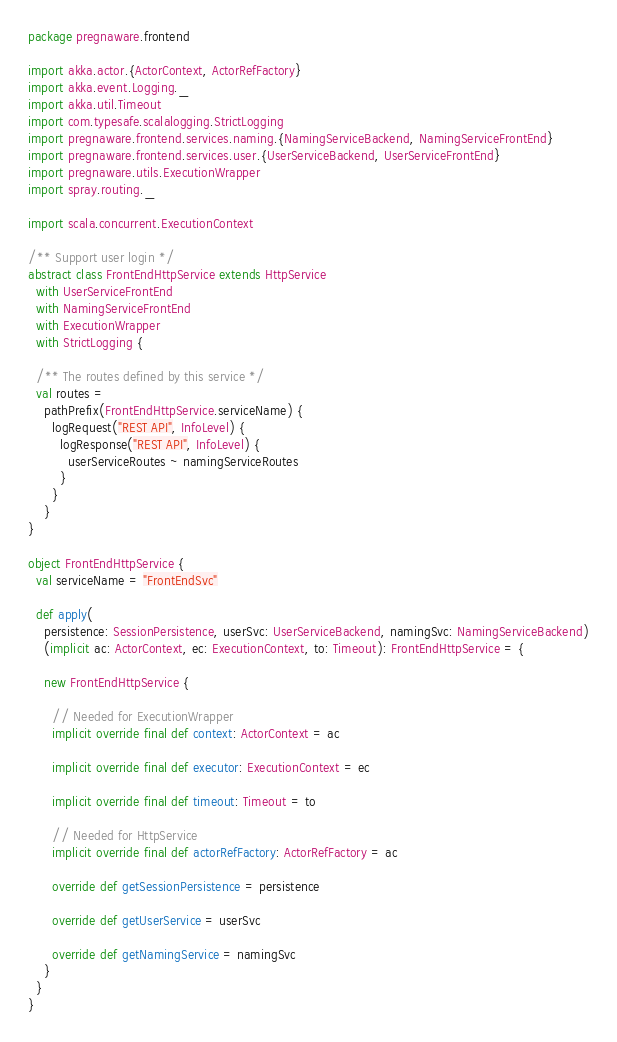<code> <loc_0><loc_0><loc_500><loc_500><_Scala_>package pregnaware.frontend

import akka.actor.{ActorContext, ActorRefFactory}
import akka.event.Logging._
import akka.util.Timeout
import com.typesafe.scalalogging.StrictLogging
import pregnaware.frontend.services.naming.{NamingServiceBackend, NamingServiceFrontEnd}
import pregnaware.frontend.services.user.{UserServiceBackend, UserServiceFrontEnd}
import pregnaware.utils.ExecutionWrapper
import spray.routing._

import scala.concurrent.ExecutionContext

/** Support user login */
abstract class FrontEndHttpService extends HttpService
  with UserServiceFrontEnd
  with NamingServiceFrontEnd
  with ExecutionWrapper
  with StrictLogging {

  /** The routes defined by this service */
  val routes =
    pathPrefix(FrontEndHttpService.serviceName) {
      logRequest("REST API", InfoLevel) {
        logResponse("REST API", InfoLevel) {
          userServiceRoutes ~ namingServiceRoutes
        }
      }
    }
}

object FrontEndHttpService {
  val serviceName = "FrontEndSvc"

  def apply(
    persistence: SessionPersistence, userSvc: UserServiceBackend, namingSvc: NamingServiceBackend)
    (implicit ac: ActorContext, ec: ExecutionContext, to: Timeout): FrontEndHttpService = {

    new FrontEndHttpService {

      // Needed for ExecutionWrapper
      implicit override final def context: ActorContext = ac

      implicit override final def executor: ExecutionContext = ec

      implicit override final def timeout: Timeout = to

      // Needed for HttpService
      implicit override final def actorRefFactory: ActorRefFactory = ac

      override def getSessionPersistence = persistence

      override def getUserService = userSvc

      override def getNamingService = namingSvc
    }
  }
}</code> 